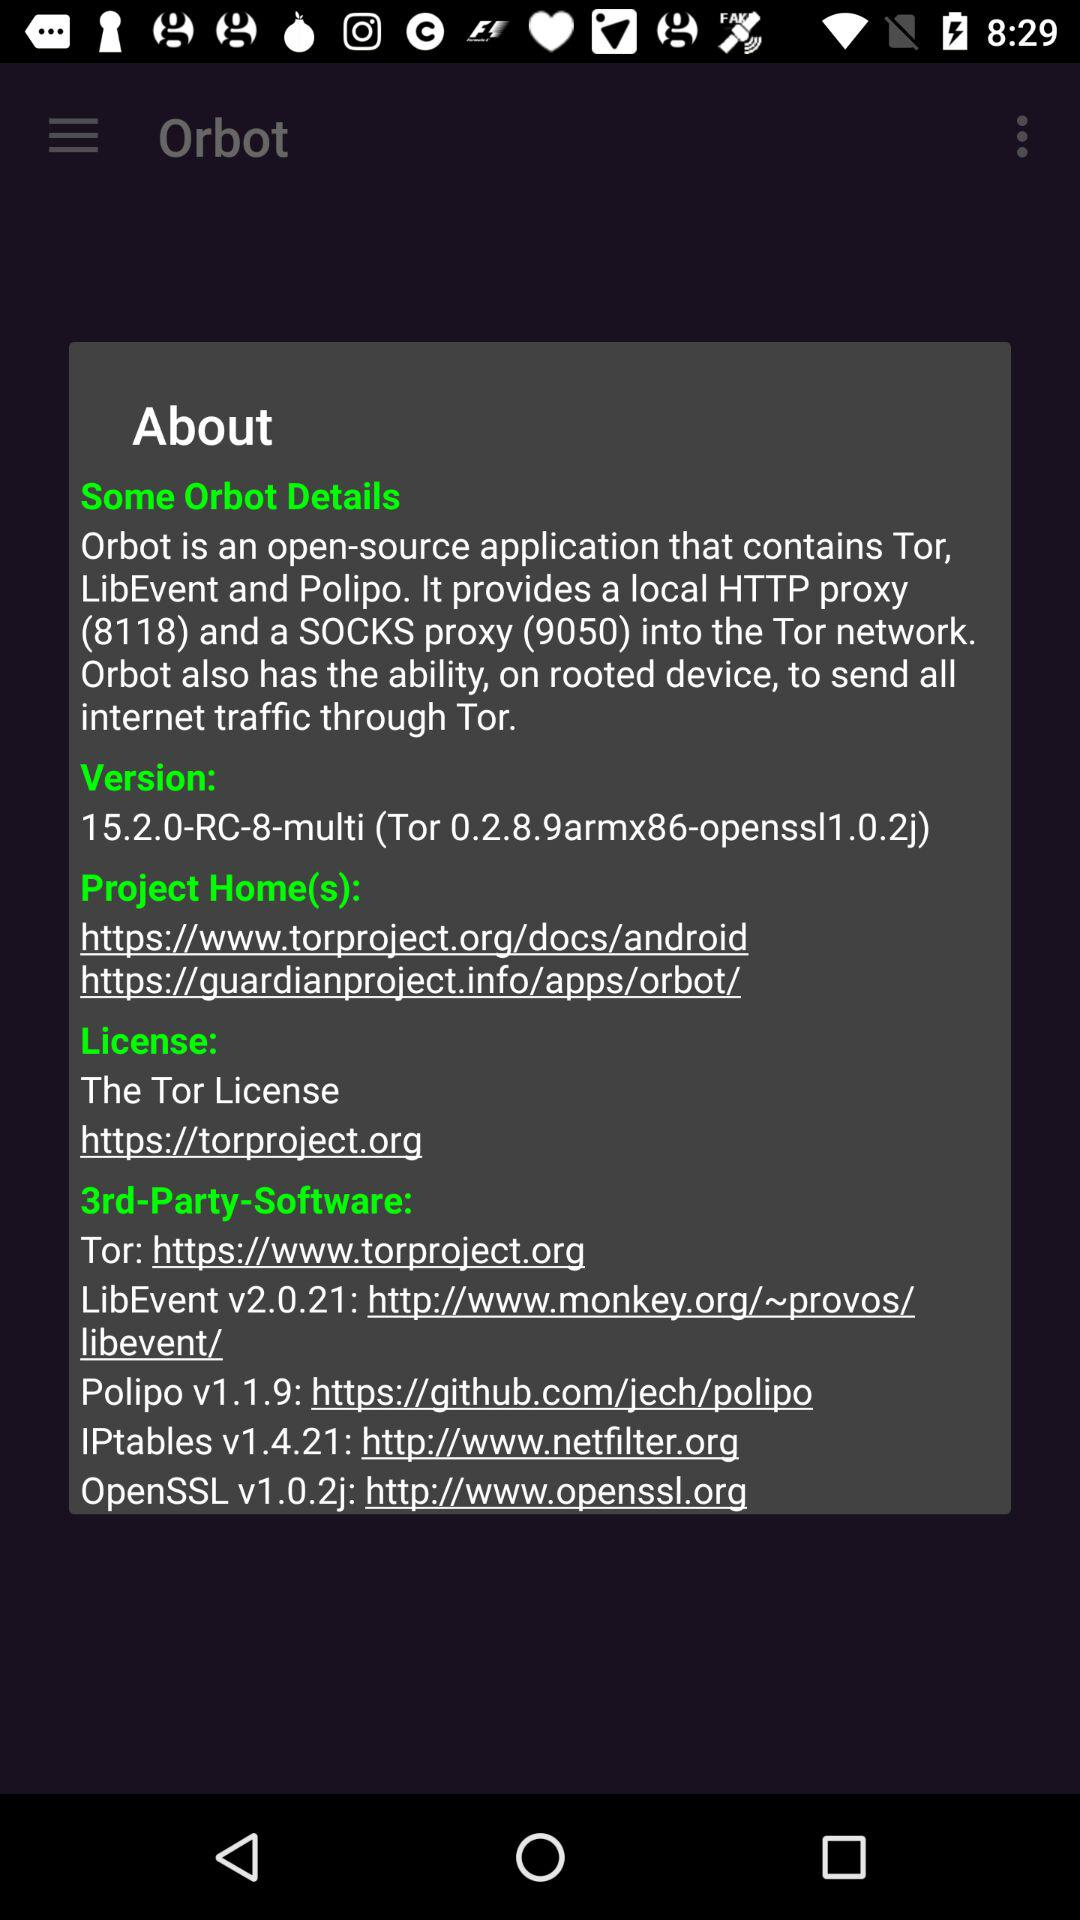How many more software links are in the '3rd-Party-Software' text than in the 'Project Home(s)' text?
Answer the question using a single word or phrase. 3 